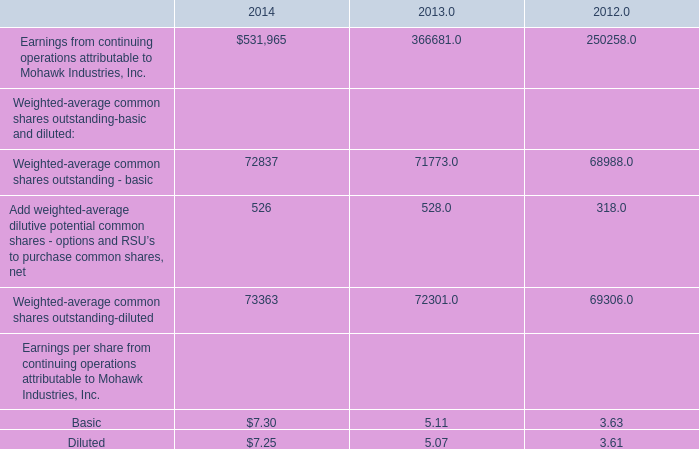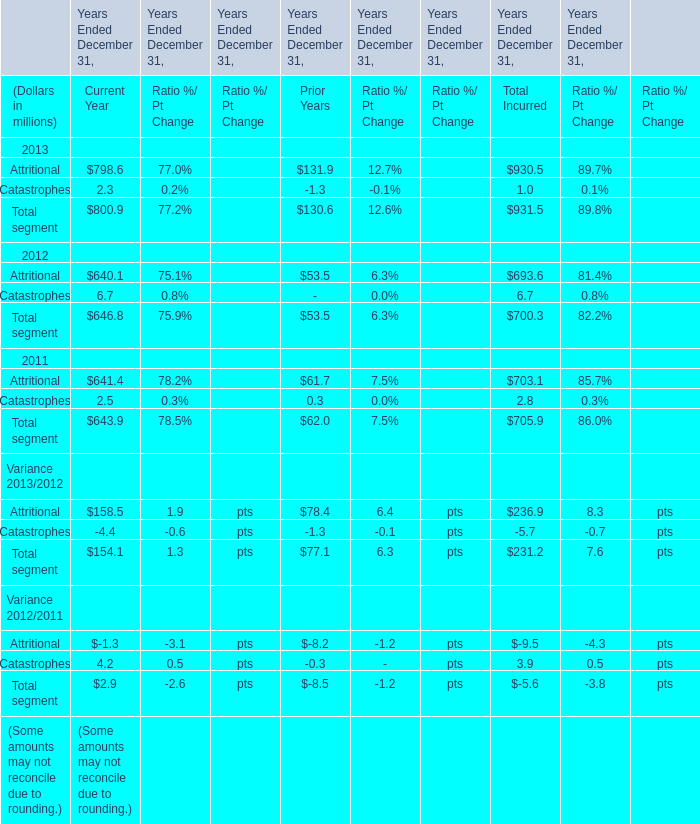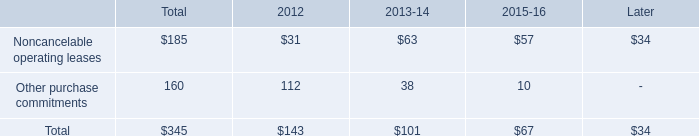what is the percent change in other purchase commitments between 2013-14 and 2015-16? 
Computations: ((10 * 38) / 38)
Answer: 10.0. 